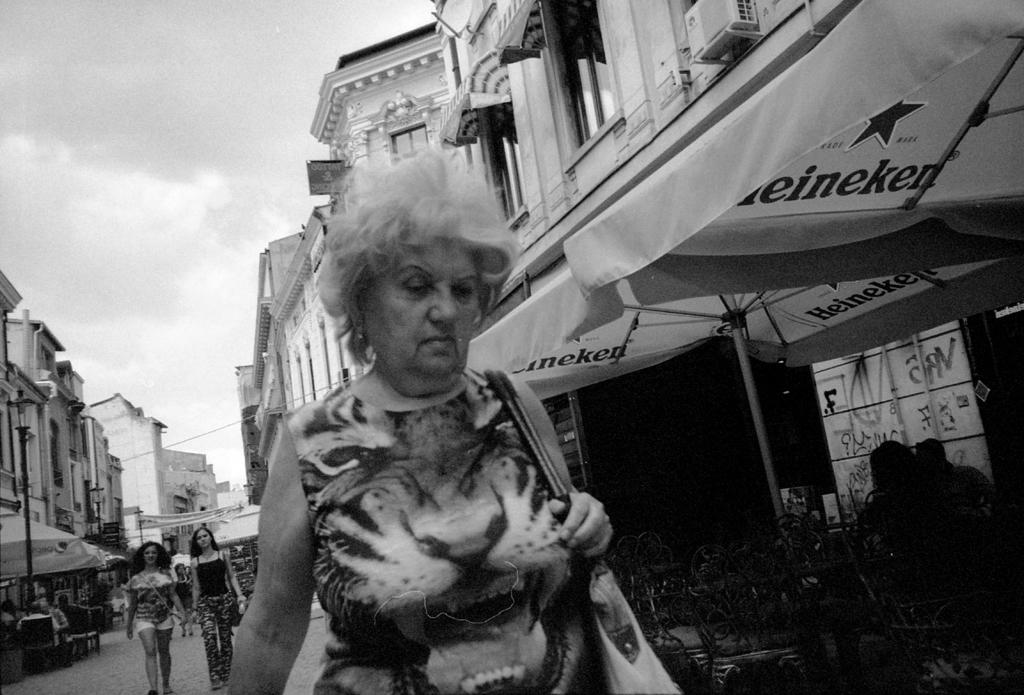Who or what can be seen in the image? There are people and buildings in the image. What is the color scheme of the image? The image is in black and white color. What can be seen in the sky in the image? Clouds are visible in the sky. What type of balloon is being used for teaching purposes in the image? There is no balloon present in the image, and no teaching is depicted. 